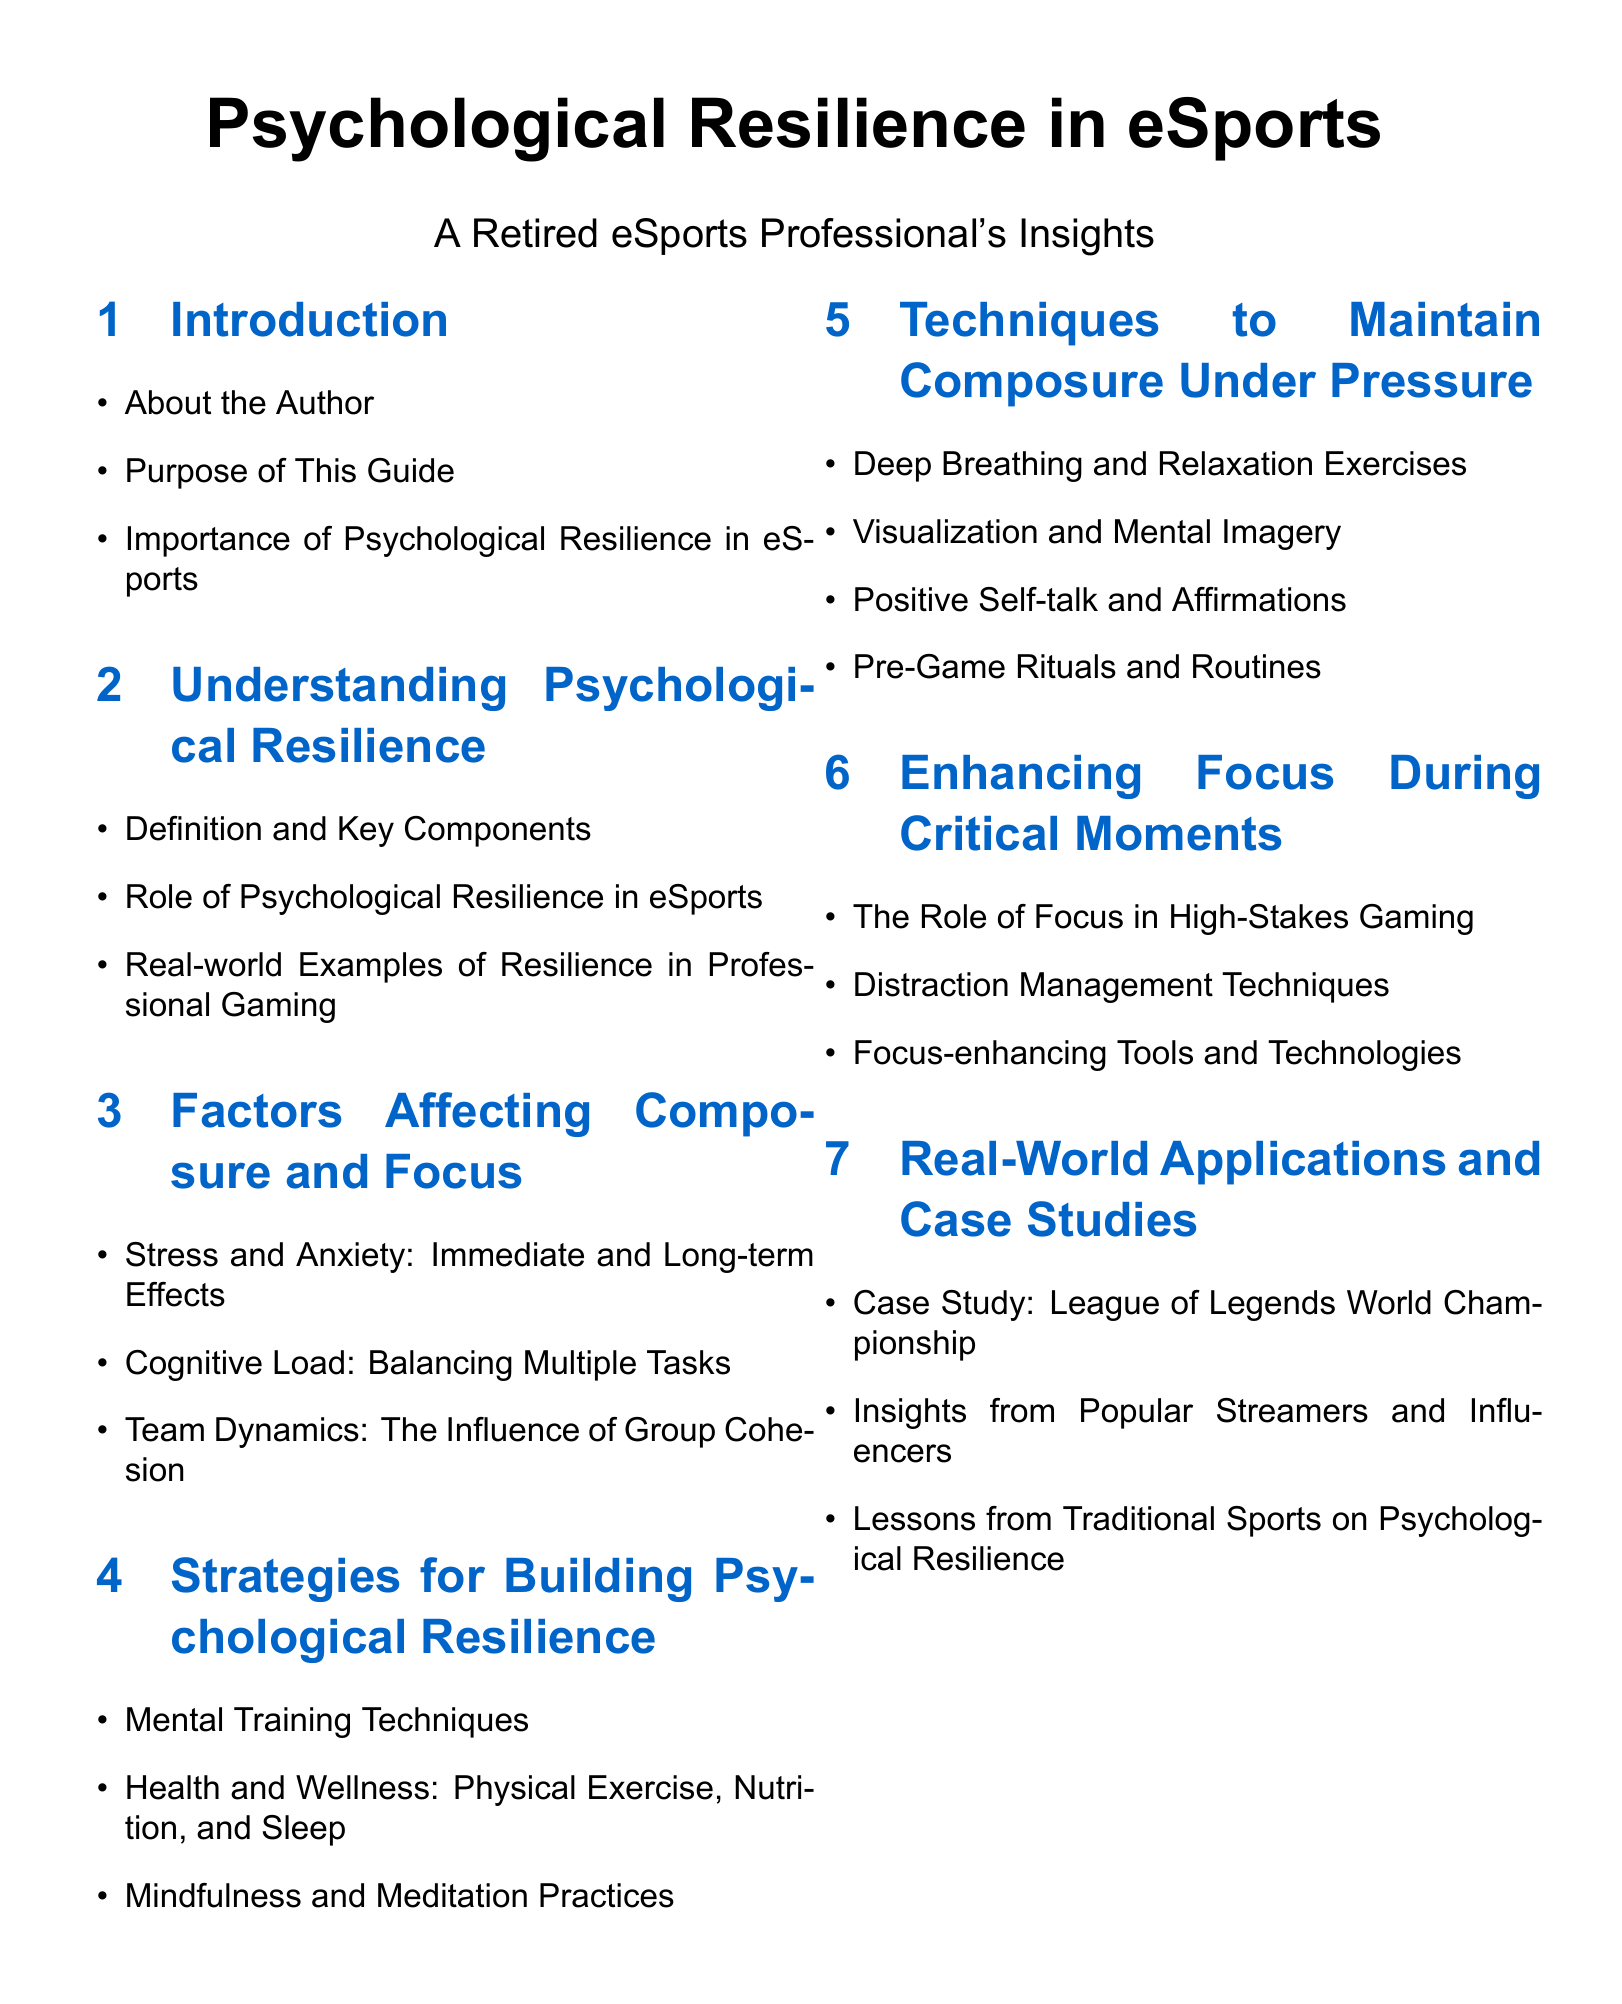What is the title of the document? The title is provided at the top of the document, which is "Psychological Resilience in eSports."
Answer: Psychological Resilience in eSports Who is the author of the document? The author is mentioned in the document as "A Retired eSports Professional's Insights."
Answer: A Retired eSports Professional's Insights What is the purpose of this guide? The purpose is outlined in the introduction section, but not explicitly stated. It concerns psychological resilience in eSports.
Answer: Purpose of This Guide What is one technique mentioned for maintaining composure under pressure? The techniques for maintaining composure are listed under the section "Techniques to Maintain Composure Under Pressure," one of which is deep breathing.
Answer: Deep Breathing How many main sections are there in the document? The main sections of the document are listed in the table of contents; there are seven main sections.
Answer: Seven What role does focus play in high-stakes gaming? This information is discussed in the section "Enhancing Focus During Critical Moments."
Answer: The Role of Focus in High-Stakes Gaming Which mental training technique is recommended? The section "Strategies for Building Psychological Resilience" lists mental training techniques, but one specific technique mentioned is not explicitly provided in the document.
Answer: Mental Training Techniques What is a case study mentioned in the document? The case studies provided will inform readers about real-world applications and one mentioned is the League of Legends World Championship.
Answer: League of Legends World Championship Which section addresses stress and anxiety? The section "Factors Affecting Composure and Focus" addresses stress and anxiety.
Answer: Factors Affecting Composure and Focus 